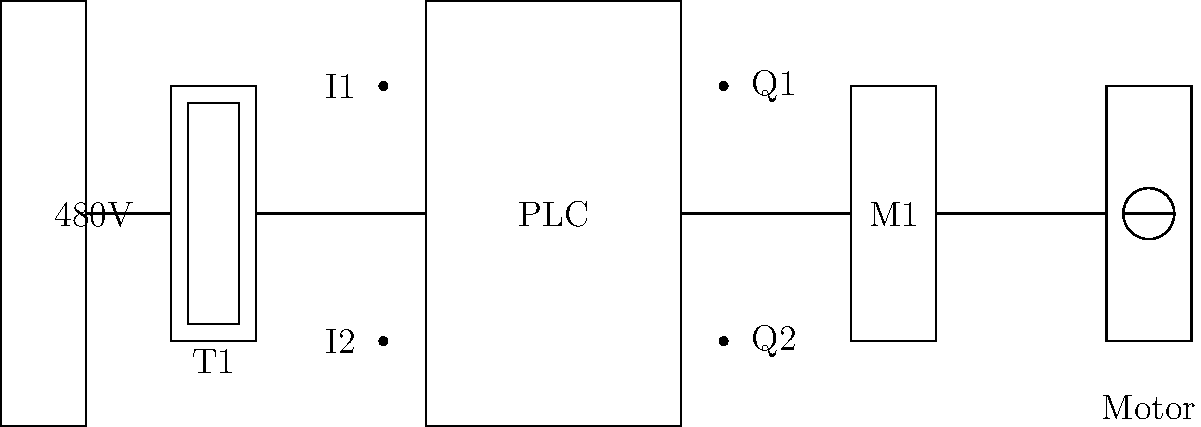In the given industrial control system schematic, what is the most likely purpose of the component labeled "T1", and how does it contribute to the overall system operation? To answer this question, let's analyze the schematic step-by-step:

1. The leftmost component is labeled "480V", indicating the main power supply for the system.

2. The component labeled "T1" is positioned between the power supply and the PLC (Programmable Logic Controller).

3. The symbol for "T1" consists of two rectangles, one inside the other. This is a common representation for a transformer in electrical schematics.

4. Given that the input power is 480V and the component is placed before the PLC, we can deduce that "T1" is likely a step-down transformer.

5. Step-down transformers are commonly used in industrial control systems to reduce the high voltage from the main power supply to a lower voltage suitable for control circuits and PLCs.

6. Typical control voltage in industrial systems is often 120V or 24V, which is much lower than the 480V input.

7. The PLC, motor starter (M1), and motor are connected in series after the transformer, indicating they all operate on the lower voltage provided by the transformer.

8. This arrangement ensures that the sensitive control components (PLC and motor starter) are protected from the high voltage of the main power supply.

9. The step-down transformer also provides electrical isolation between the high-voltage power circuit and the low-voltage control circuit, enhancing safety and reducing electromagnetic interference.

Therefore, the most likely purpose of "T1" is to step down the voltage from 480V to a lower voltage suitable for the control system components, while also providing electrical isolation.
Answer: Step-down transformer for voltage reduction and electrical isolation 